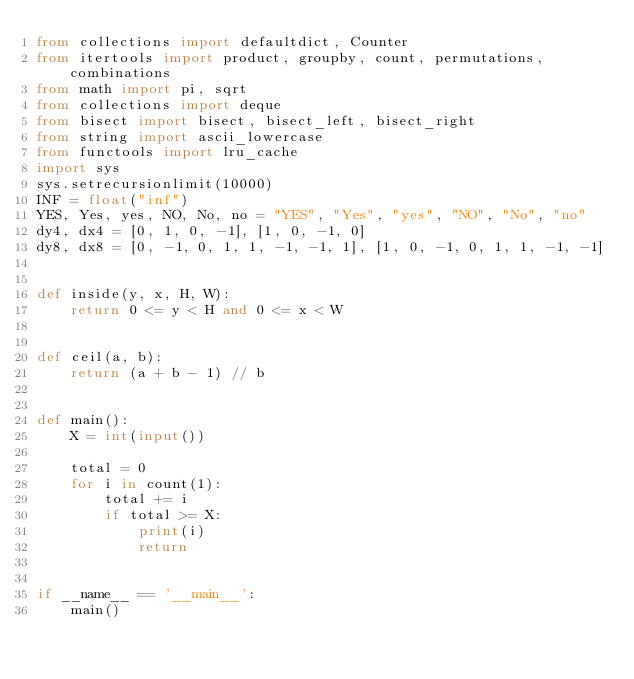<code> <loc_0><loc_0><loc_500><loc_500><_Python_>from collections import defaultdict, Counter
from itertools import product, groupby, count, permutations, combinations
from math import pi, sqrt
from collections import deque
from bisect import bisect, bisect_left, bisect_right
from string import ascii_lowercase
from functools import lru_cache
import sys
sys.setrecursionlimit(10000)
INF = float("inf")
YES, Yes, yes, NO, No, no = "YES", "Yes", "yes", "NO", "No", "no"
dy4, dx4 = [0, 1, 0, -1], [1, 0, -1, 0]
dy8, dx8 = [0, -1, 0, 1, 1, -1, -1, 1], [1, 0, -1, 0, 1, 1, -1, -1]


def inside(y, x, H, W):
    return 0 <= y < H and 0 <= x < W


def ceil(a, b):
    return (a + b - 1) // b


def main():
    X = int(input())

    total = 0
    for i in count(1):
        total += i
        if total >= X:
            print(i)
            return


if __name__ == '__main__':
    main()
</code> 